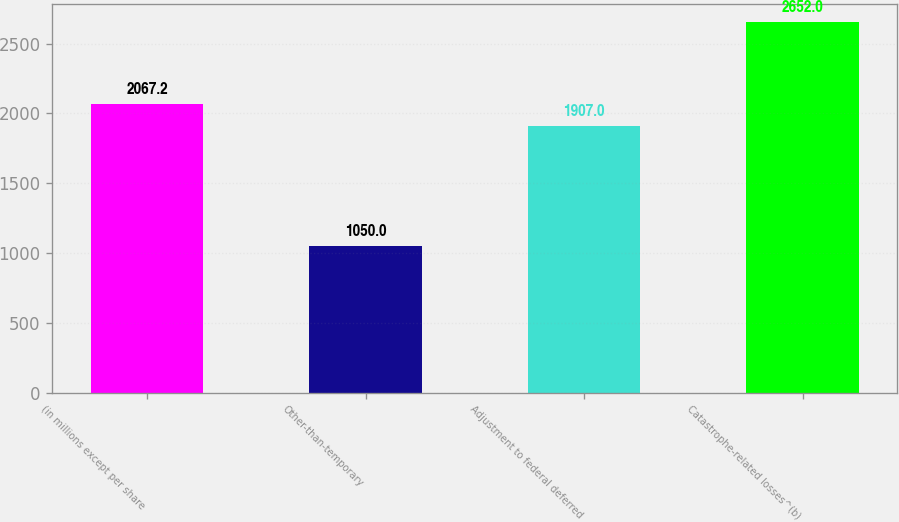Convert chart. <chart><loc_0><loc_0><loc_500><loc_500><bar_chart><fcel>(in millions except per share<fcel>Other-than-temporary<fcel>Adjustment to federal deferred<fcel>Catastrophe-related losses^(b)<nl><fcel>2067.2<fcel>1050<fcel>1907<fcel>2652<nl></chart> 